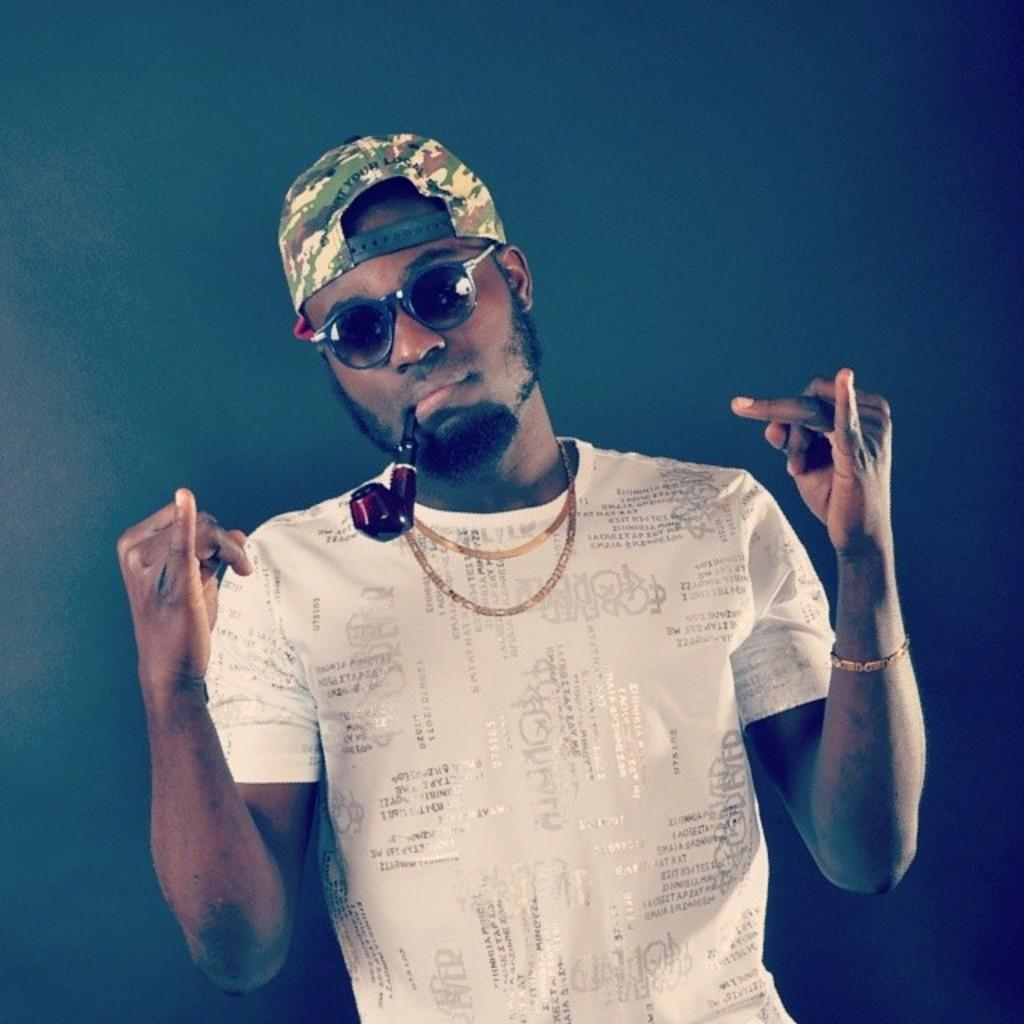What can be seen in the image? There is a person in the image. What is the person wearing on their head? The person is wearing a cap. What type of eyewear is the person wearing? The person is wearing goggles. What color is the person's t-shirt? The person is wearing a white t-shirt. What is the person holding in their mouth? The person is holding a pipe in their mouth. How many pages can be seen in the image? There are no pages present in the image; it features a person wearing a cap, goggles, and a white t-shirt, holding a pipe in their mouth. What type of actor can be seen in the image? There is no actor present in the image; it features a person wearing a cap, goggles, and a white t-shirt, holding a pipe in their mouth. 